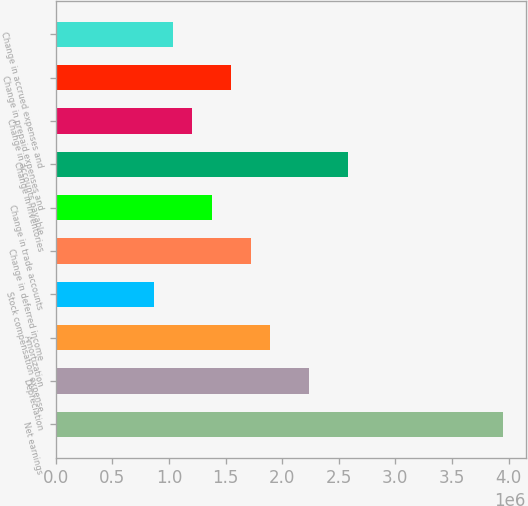<chart> <loc_0><loc_0><loc_500><loc_500><bar_chart><fcel>Net earnings<fcel>Depreciation<fcel>Amortization<fcel>Stock compensation expense<fcel>Change in deferred income<fcel>Change in trade accounts<fcel>Change in inventories<fcel>Change in accounts payable<fcel>Change in prepaid expenses and<fcel>Change in accrued expenses and<nl><fcel>3.9525e+06<fcel>2.23667e+06<fcel>1.8935e+06<fcel>864005<fcel>1.72192e+06<fcel>1.37875e+06<fcel>2.57984e+06<fcel>1.20717e+06<fcel>1.55034e+06<fcel>1.03559e+06<nl></chart> 